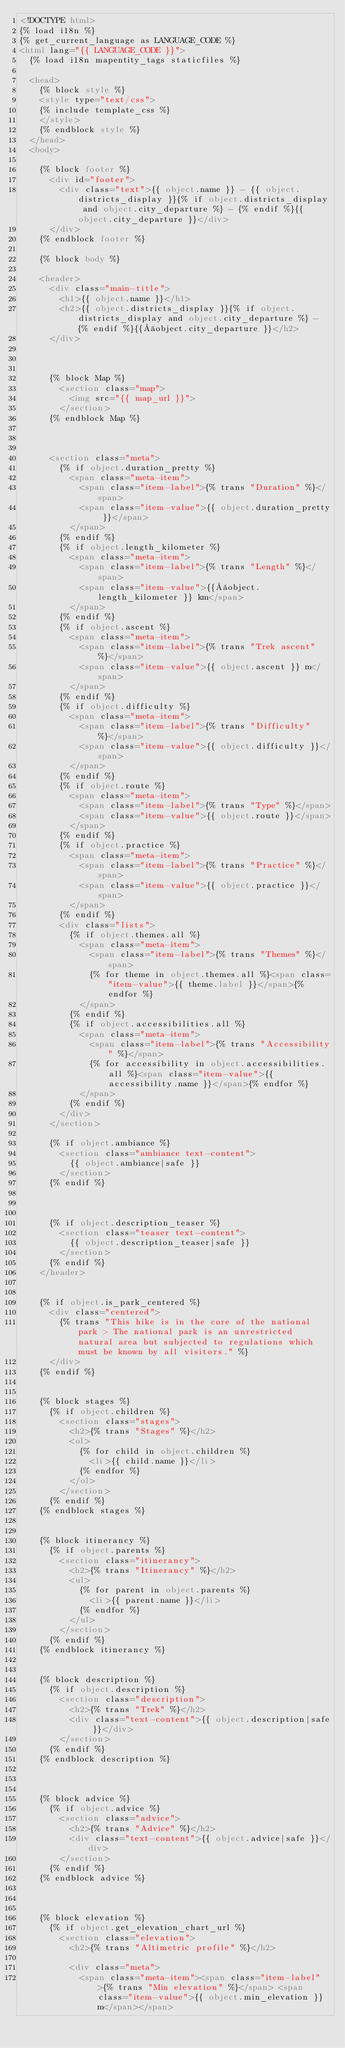Convert code to text. <code><loc_0><loc_0><loc_500><loc_500><_HTML_><!DOCTYPE html>
{% load i18n %}
{% get_current_language as LANGUAGE_CODE %}
<html lang="{{ LANGUAGE_CODE }}">
	{% load i18n mapentity_tags staticfiles %}

	<head>
		{% block style %}
		<style type="text/css">
		{% include template_css %}
		</style>
		{% endblock style %}
	</head>
	<body>

		{% block footer %}
			<div id="footer">
				<div class="text">{{ object.name }} - {{ object.districts_display }}{% if object.districts_display and object.city_departure %} - {% endif %}{{ object.city_departure }}</div>
			</div>
		{% endblock footer %}

		{% block body %}

		<header>
			<div class="main-title">
				<h1>{{ object.name }}</h1>
				<h2>{{ object.districts_display }}{% if object.districts_display and object.city_departure %} - {% endif %}{{ object.city_departure }}</h2>
			</div>



			{% block Map %}
				<section class="map">
					<img src="{{ map_url }}">
				</section>
			{% endblock Map %}



			<section class="meta">
				{% if object.duration_pretty %}
					<span class="meta-item">
						<span class="item-label">{% trans "Duration" %}</span>
						<span class="item-value">{{ object.duration_pretty }}</span>
					</span>
				{% endif %}
				{% if object.length_kilometer %}
					<span class="meta-item">
						<span class="item-label">{% trans "Length" %}</span>
						<span class="item-value">{{ object.length_kilometer }} km</span>
					</span>
				{% endif %}
				{% if object.ascent %}
					<span class="meta-item">
						<span class="item-label">{% trans "Trek ascent" %}</span>
						<span class="item-value">{{ object.ascent }} m</span>
					</span>
				{% endif %}
				{% if object.difficulty %}
					<span class="meta-item">
						<span class="item-label">{% trans "Difficulty" %}</span>
						<span class="item-value">{{ object.difficulty }}</span>
					</span>
				{% endif %}
				{% if object.route %}
					<span class="meta-item">
						<span class="item-label">{% trans "Type" %}</span>
						<span class="item-value">{{ object.route }}</span>
					</span>
				{% endif %}
				{% if object.practice %}
					<span class="meta-item">
						<span class="item-label">{% trans "Practice" %}</span>
						<span class="item-value">{{ object.practice }}</span>
					</span>
				{% endif %}
				<div class="lists">
					{% if object.themes.all %}
						<span class="meta-item">
							<span class="item-label">{% trans "Themes" %}</span>
							{% for theme in object.themes.all %}<span class="item-value">{{ theme.label }}</span>{% endfor %}
						</span>
					{% endif %}
					{% if object.accessibilities.all %}
						<span class="meta-item">
							<span class="item-label">{% trans "Accessibility" %}</span>
							{% for accessibility in object.accessibilities.all %}<span class="item-value">{{ accessibility.name }}</span>{% endfor %}
						</span>
					{% endif %}
				</div>
			</section>

			{% if object.ambiance %}
				<section class="ambiance text-content">
					{{ object.ambiance|safe }}
				</section>
			{% endif %}



			{% if object.description_teaser %}
				<section class="teaser text-content">
					{{ object.description_teaser|safe }}
				</section>
			{% endif %}
		</header>


		{% if object.is_park_centered %}
			<div class="centered">
				{% trans "This hike is in the core of the national park > The national park is an unrestricted natural area but subjected to regulations which must be known by all visitors." %}
			</div>
		{% endif %}


		{% block stages %}
			{% if object.children %}
				<section class="stages">
					<h2>{% trans "Stages" %}</h2>
					<ol>
						{% for child in object.children %}
							<li>{{ child.name }}</li>
						{% endfor %}
					</ol>
				</section>
			{% endif %}
		{% endblock stages %}


		{% block itinerancy %}
			{% if object.parents %}
				<section class="itinerancy">
					<h2>{% trans "Itinerancy" %}</h2>
					<ul>
						{% for parent in object.parents %}
							<li>{{ parent.name }}</li>
						{% endfor %}
					</ul>
				</section>
			{% endif %}
		{% endblock itinerancy %}


		{% block description %}
			{% if object.description %}
				<section class="description">
					<h2>{% trans "Trek" %}</h2>
					<div class="text-content">{{ object.description|safe }}</div>
				</section>
			{% endif %}
		{% endblock description %}



		{% block advice %}
			{% if object.advice %}
				<section class="advice">
					<h2>{% trans "Advice" %}</h2>
					<div class="text-content">{{ object.advice|safe }}</div>
				</section>
			{% endif %}
		{% endblock advice %}



		{% block elevation %}
			{% if object.get_elevation_chart_url %}
				<section class="elevation">
					<h2>{% trans "Altimetric profile" %}</h2>

					<div class="meta">
						<span class="meta-item"><span class="item-label">{% trans "Min elevation" %}</span> <span class="item-value">{{ object.min_elevation }} m</span></span></code> 